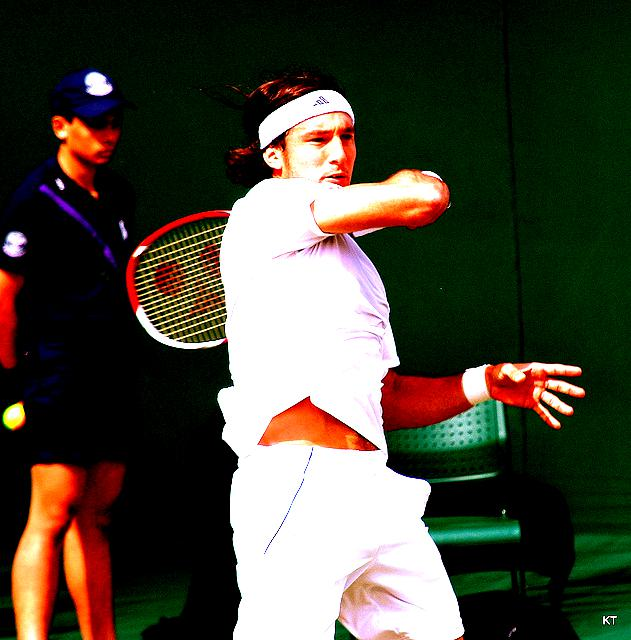Describe the action being captured in the image. The image captures a tennis player in the midst of a backhand stroke, his focus intense on the approaching ball. You can notice the dynamic motion and athleticism required for the sport. What can we infer about the setting of this event? It appears to be an outdoor tennis match, possibly during a professional tournament considering the presence of an official in the background and the green backdrop, which is commonly used at such events. 